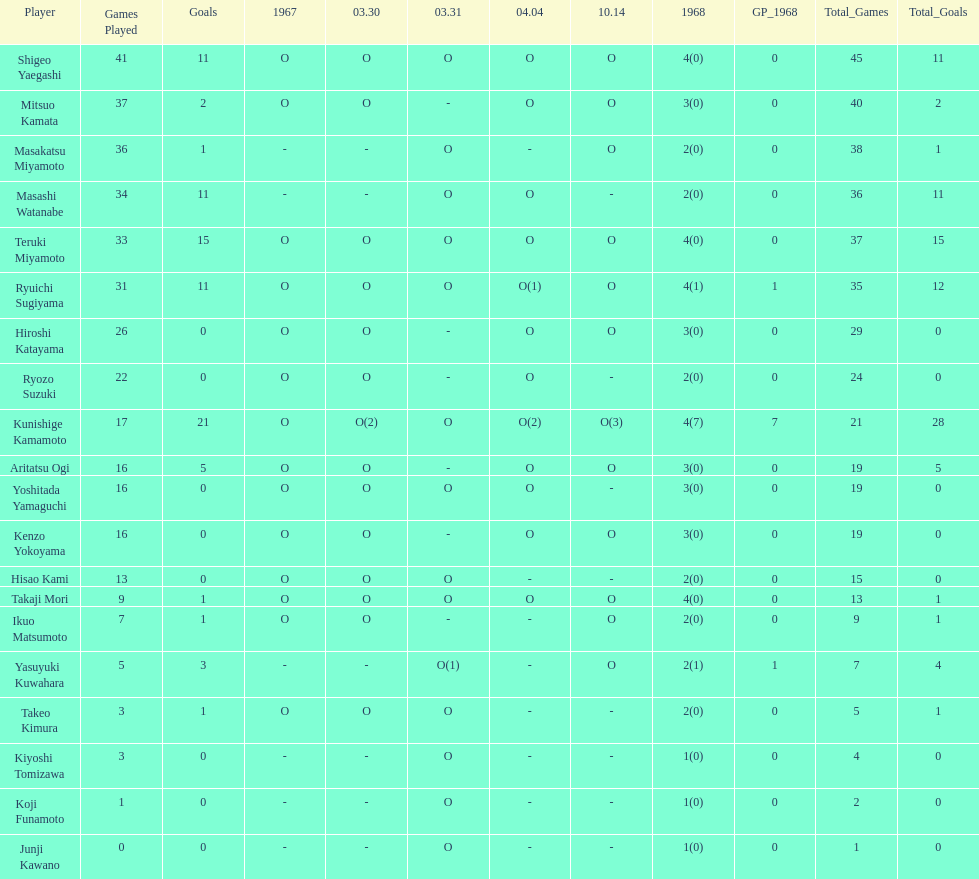Who had more points takaji mori or junji kawano? Takaji Mori. 